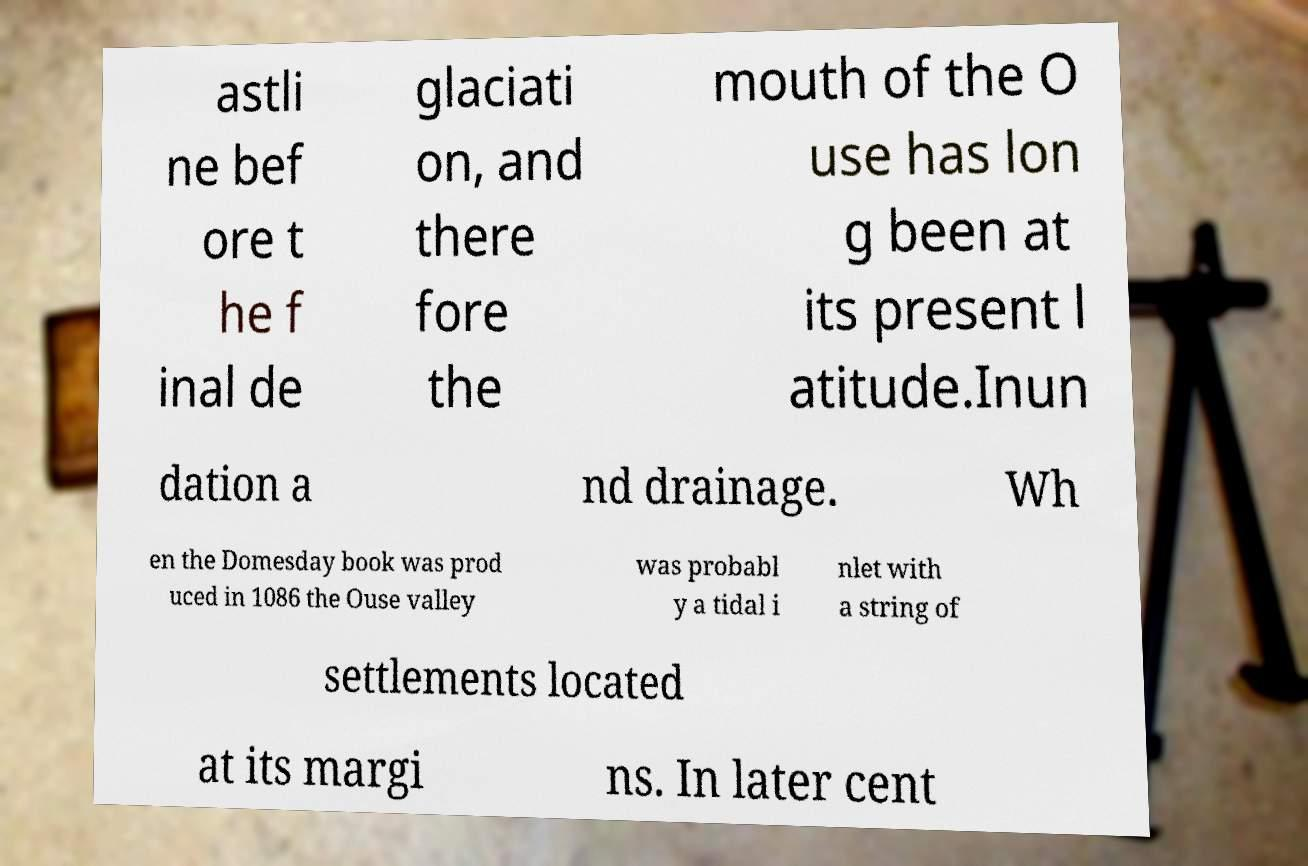For documentation purposes, I need the text within this image transcribed. Could you provide that? astli ne bef ore t he f inal de glaciati on, and there fore the mouth of the O use has lon g been at its present l atitude.Inun dation a nd drainage. Wh en the Domesday book was prod uced in 1086 the Ouse valley was probabl y a tidal i nlet with a string of settlements located at its margi ns. In later cent 